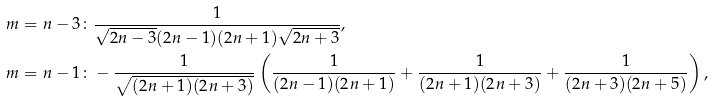Convert formula to latex. <formula><loc_0><loc_0><loc_500><loc_500>m = n - 3 \colon & \frac { 1 } { \sqrt { 2 n - 3 } ( 2 n - 1 ) ( 2 n + 1 ) \sqrt { 2 n + 3 } } , \\ m = n - 1 \colon & - \frac { 1 } { \sqrt { ( 2 n + 1 ) ( 2 n + 3 ) } } \left ( \frac { 1 } { ( 2 n - 1 ) ( 2 n + 1 ) } + \frac { 1 } { ( 2 n + 1 ) ( 2 n + 3 ) } + \frac { 1 } { ( 2 n + 3 ) ( 2 n + 5 ) } \right ) ,</formula> 